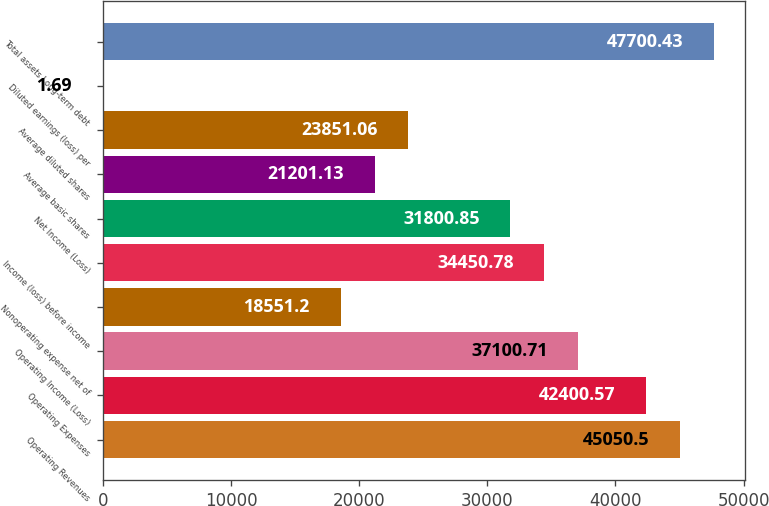Convert chart to OTSL. <chart><loc_0><loc_0><loc_500><loc_500><bar_chart><fcel>Operating Revenues<fcel>Operating Expenses<fcel>Operating Income (Loss)<fcel>Nonoperating expense net of<fcel>Income (loss) before income<fcel>Net Income (Loss)<fcel>Average basic shares<fcel>Average diluted shares<fcel>Diluted earnings (loss) per<fcel>Total assets Long-term debt<nl><fcel>45050.5<fcel>42400.6<fcel>37100.7<fcel>18551.2<fcel>34450.8<fcel>31800.8<fcel>21201.1<fcel>23851.1<fcel>1.69<fcel>47700.4<nl></chart> 